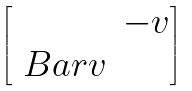<formula> <loc_0><loc_0><loc_500><loc_500>\begin{bmatrix} & - v \\ \ B a r { v } & \end{bmatrix}</formula> 